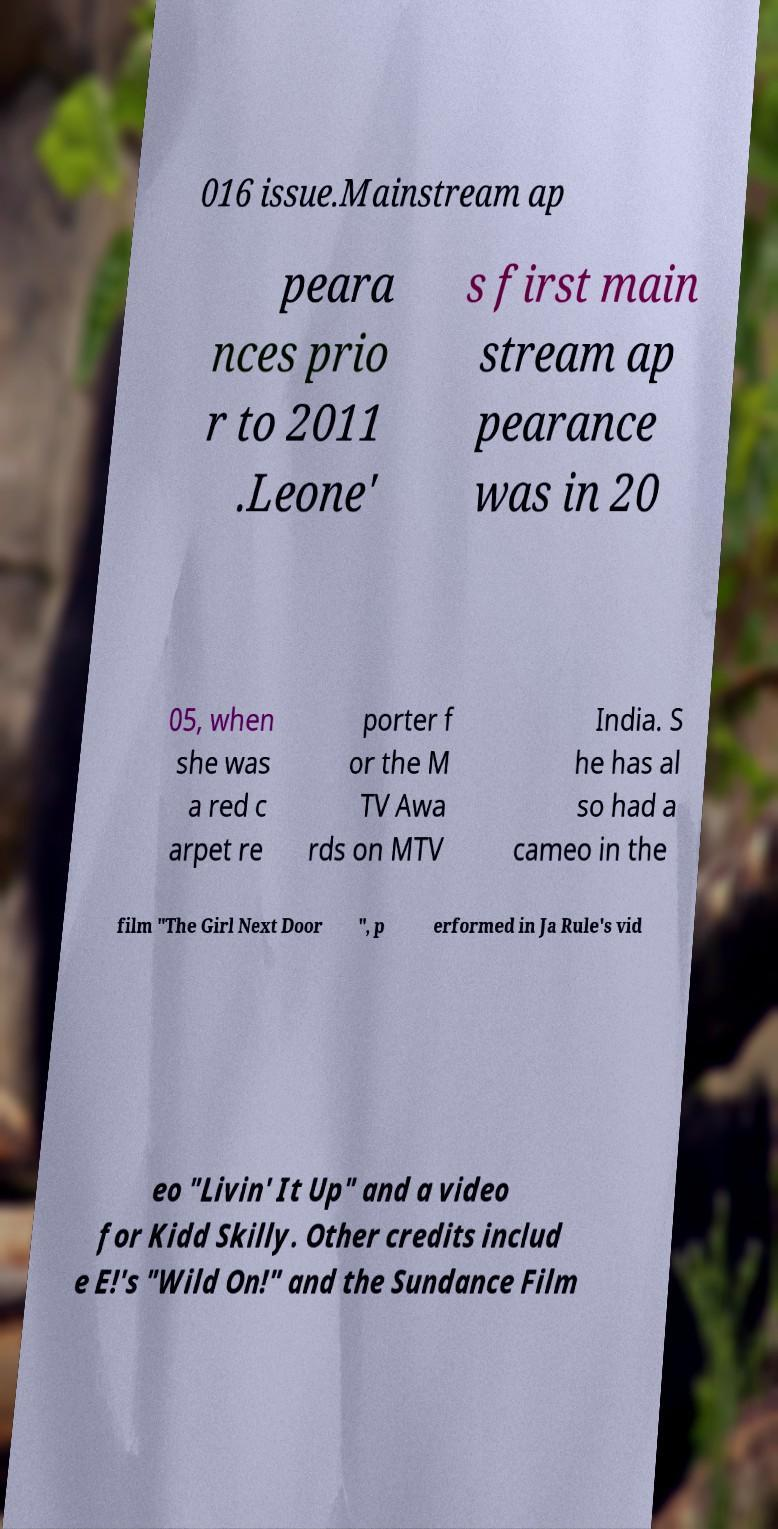Can you accurately transcribe the text from the provided image for me? 016 issue.Mainstream ap peara nces prio r to 2011 .Leone' s first main stream ap pearance was in 20 05, when she was a red c arpet re porter f or the M TV Awa rds on MTV India. S he has al so had a cameo in the film "The Girl Next Door ", p erformed in Ja Rule's vid eo "Livin' It Up" and a video for Kidd Skilly. Other credits includ e E!'s "Wild On!" and the Sundance Film 